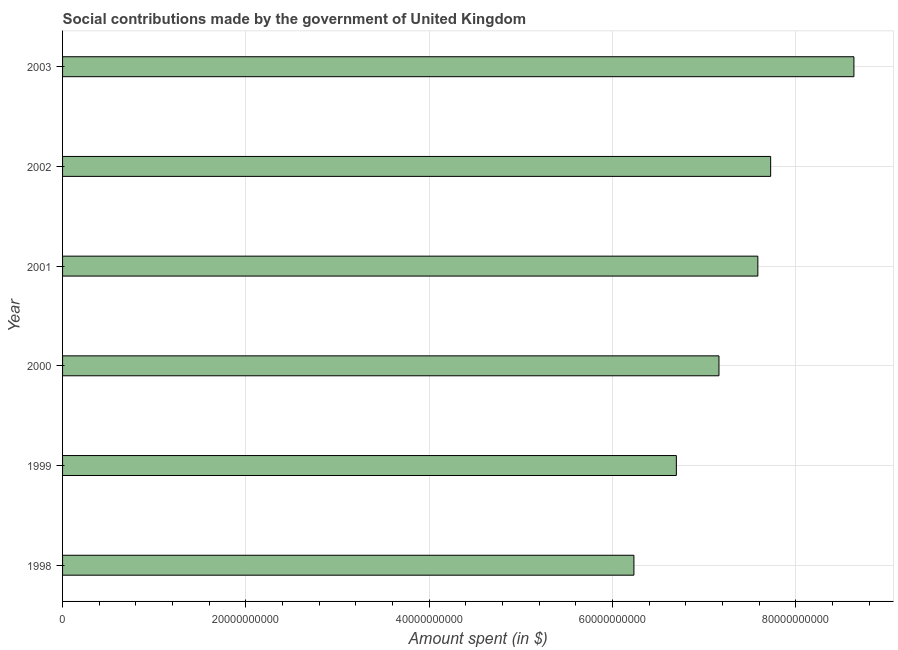What is the title of the graph?
Provide a succinct answer. Social contributions made by the government of United Kingdom. What is the label or title of the X-axis?
Ensure brevity in your answer.  Amount spent (in $). What is the amount spent in making social contributions in 1998?
Your response must be concise. 6.23e+1. Across all years, what is the maximum amount spent in making social contributions?
Provide a short and direct response. 8.63e+1. Across all years, what is the minimum amount spent in making social contributions?
Provide a succinct answer. 6.23e+1. What is the sum of the amount spent in making social contributions?
Your response must be concise. 4.40e+11. What is the difference between the amount spent in making social contributions in 1998 and 2000?
Your answer should be compact. -9.28e+09. What is the average amount spent in making social contributions per year?
Your answer should be compact. 7.34e+1. What is the median amount spent in making social contributions?
Your response must be concise. 7.37e+1. In how many years, is the amount spent in making social contributions greater than 68000000000 $?
Offer a very short reply. 4. Do a majority of the years between 1998 and 2003 (inclusive) have amount spent in making social contributions greater than 60000000000 $?
Your response must be concise. Yes. What is the ratio of the amount spent in making social contributions in 1999 to that in 2000?
Your response must be concise. 0.94. Is the amount spent in making social contributions in 1999 less than that in 2003?
Give a very brief answer. Yes. What is the difference between the highest and the second highest amount spent in making social contributions?
Your response must be concise. 9.08e+09. What is the difference between the highest and the lowest amount spent in making social contributions?
Provide a short and direct response. 2.40e+1. In how many years, is the amount spent in making social contributions greater than the average amount spent in making social contributions taken over all years?
Your response must be concise. 3. How many bars are there?
Offer a terse response. 6. Are all the bars in the graph horizontal?
Offer a very short reply. Yes. How many years are there in the graph?
Provide a short and direct response. 6. What is the Amount spent (in $) of 1998?
Your response must be concise. 6.23e+1. What is the Amount spent (in $) in 1999?
Provide a succinct answer. 6.70e+1. What is the Amount spent (in $) in 2000?
Your response must be concise. 7.16e+1. What is the Amount spent (in $) in 2001?
Provide a succinct answer. 7.59e+1. What is the Amount spent (in $) in 2002?
Provide a short and direct response. 7.72e+1. What is the Amount spent (in $) in 2003?
Your answer should be very brief. 8.63e+1. What is the difference between the Amount spent (in $) in 1998 and 1999?
Offer a very short reply. -4.63e+09. What is the difference between the Amount spent (in $) in 1998 and 2000?
Offer a very short reply. -9.28e+09. What is the difference between the Amount spent (in $) in 1998 and 2001?
Offer a very short reply. -1.35e+1. What is the difference between the Amount spent (in $) in 1998 and 2002?
Provide a short and direct response. -1.49e+1. What is the difference between the Amount spent (in $) in 1998 and 2003?
Offer a very short reply. -2.40e+1. What is the difference between the Amount spent (in $) in 1999 and 2000?
Your response must be concise. -4.65e+09. What is the difference between the Amount spent (in $) in 1999 and 2001?
Give a very brief answer. -8.89e+09. What is the difference between the Amount spent (in $) in 1999 and 2002?
Keep it short and to the point. -1.03e+1. What is the difference between the Amount spent (in $) in 1999 and 2003?
Ensure brevity in your answer.  -1.94e+1. What is the difference between the Amount spent (in $) in 2000 and 2001?
Provide a succinct answer. -4.24e+09. What is the difference between the Amount spent (in $) in 2000 and 2002?
Provide a succinct answer. -5.64e+09. What is the difference between the Amount spent (in $) in 2000 and 2003?
Provide a succinct answer. -1.47e+1. What is the difference between the Amount spent (in $) in 2001 and 2002?
Offer a very short reply. -1.40e+09. What is the difference between the Amount spent (in $) in 2001 and 2003?
Your answer should be compact. -1.05e+1. What is the difference between the Amount spent (in $) in 2002 and 2003?
Your answer should be compact. -9.08e+09. What is the ratio of the Amount spent (in $) in 1998 to that in 2000?
Provide a succinct answer. 0.87. What is the ratio of the Amount spent (in $) in 1998 to that in 2001?
Offer a very short reply. 0.82. What is the ratio of the Amount spent (in $) in 1998 to that in 2002?
Offer a very short reply. 0.81. What is the ratio of the Amount spent (in $) in 1998 to that in 2003?
Keep it short and to the point. 0.72. What is the ratio of the Amount spent (in $) in 1999 to that in 2000?
Provide a succinct answer. 0.94. What is the ratio of the Amount spent (in $) in 1999 to that in 2001?
Your answer should be very brief. 0.88. What is the ratio of the Amount spent (in $) in 1999 to that in 2002?
Give a very brief answer. 0.87. What is the ratio of the Amount spent (in $) in 1999 to that in 2003?
Give a very brief answer. 0.78. What is the ratio of the Amount spent (in $) in 2000 to that in 2001?
Make the answer very short. 0.94. What is the ratio of the Amount spent (in $) in 2000 to that in 2002?
Make the answer very short. 0.93. What is the ratio of the Amount spent (in $) in 2000 to that in 2003?
Provide a short and direct response. 0.83. What is the ratio of the Amount spent (in $) in 2001 to that in 2002?
Offer a very short reply. 0.98. What is the ratio of the Amount spent (in $) in 2001 to that in 2003?
Make the answer very short. 0.88. What is the ratio of the Amount spent (in $) in 2002 to that in 2003?
Your response must be concise. 0.9. 